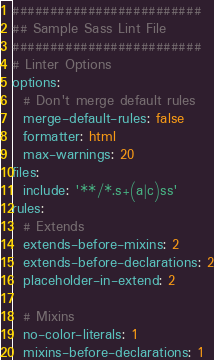<code> <loc_0><loc_0><loc_500><loc_500><_YAML_>#########################
## Sample Sass Lint File
#########################
# Linter Options
options:
  # Don't merge default rules
  merge-default-rules: false
  formatter: html
  max-warnings: 20
files:
  include: '**/*.s+(a|c)ss'
rules:
  # Extends
  extends-before-mixins: 2
  extends-before-declarations: 2
  placeholder-in-extend: 2

  # Mixins
  no-color-literals: 1
  mixins-before-declarations: 1
</code> 